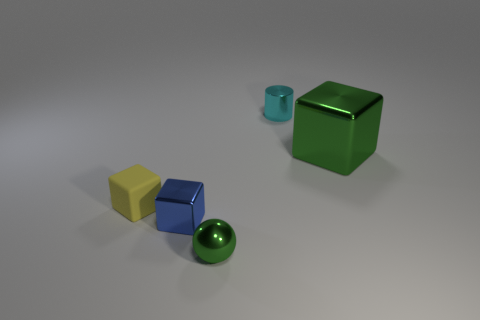Can you describe the lighting and shadows in the scene? The lighting in the scene appears to be soft, directional, and most likely coming from the upper right based on the shadow placement. Each object casts a slightly diffused shadow towards the left, indicating the light source is not extremely close. The softness of the shadows suggests either a large light source or a diffuser has been used to scatter the light, resulting in gentle shadows without sharp edges.  How would changing the light source affect the appearance of the objects and their materials? If the light source were changed, the appearance of the objects and perception of their materials would be altered significantly. A harsher, more direct light would create sharper shadows and enhance the reflective qualities of the metal and glossy surfaces, possibly causing bright highlights and stronger contrasts. Conversely, a dimmer or more diffuse light might reduce the visibility of the materials' textures and soften the appearance of the objects even further. 